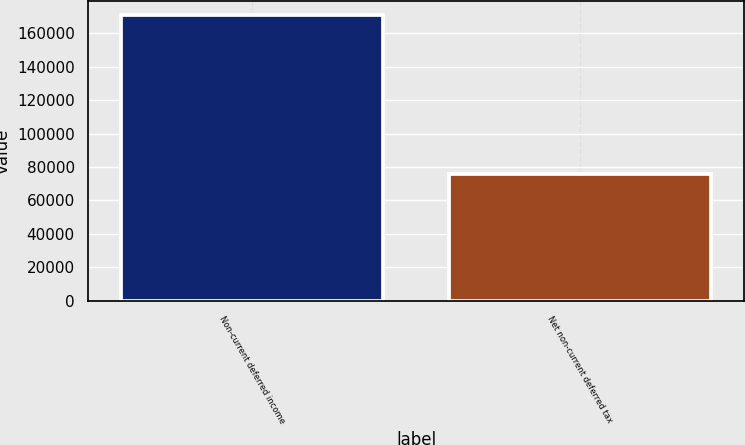<chart> <loc_0><loc_0><loc_500><loc_500><bar_chart><fcel>Non-current deferred income<fcel>Net non-current deferred tax<nl><fcel>170723<fcel>75545<nl></chart> 